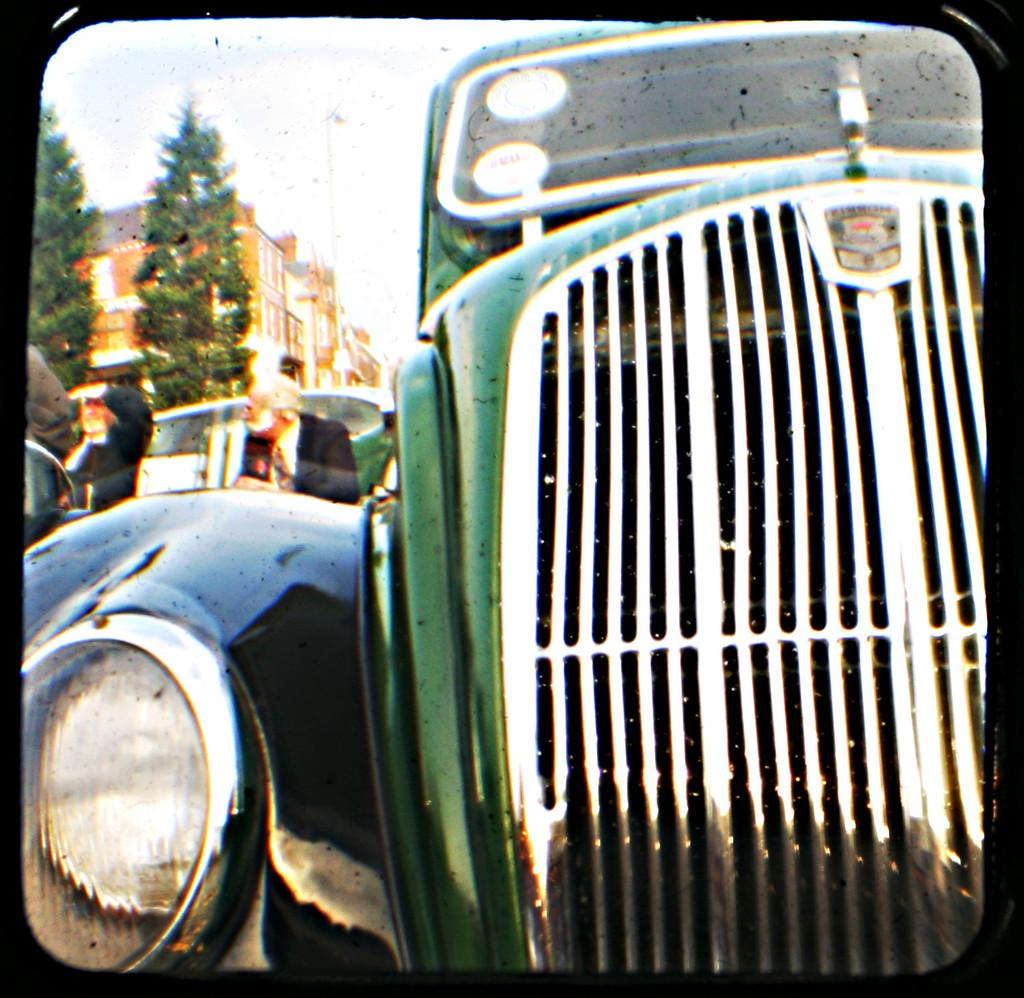What is the main subject of the image? There is a vehicle in the image. Can you describe the surroundings of the vehicle? In the background of the image, there are persons, at least one other vehicle, trees, a building, and the sky. How many vehicles can be seen in the image? There is one vehicle in the foreground and at least one other vehicle in the background. What type of filter has been applied to the image? The image has been edited with a frame filter. What type of coal is being used to treat the friction between the vehicles in the image? There is no coal or treatment of friction between vehicles mentioned or depicted in the image. 